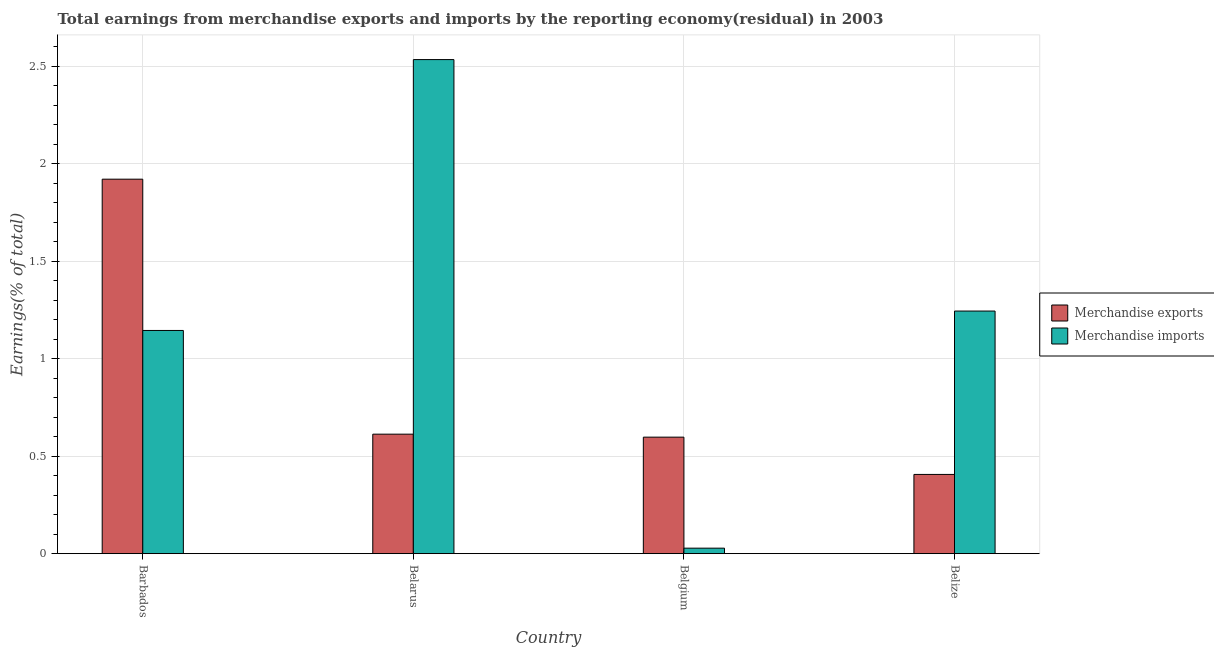Are the number of bars per tick equal to the number of legend labels?
Ensure brevity in your answer.  Yes. Are the number of bars on each tick of the X-axis equal?
Provide a succinct answer. Yes. How many bars are there on the 2nd tick from the left?
Your answer should be very brief. 2. How many bars are there on the 1st tick from the right?
Offer a very short reply. 2. What is the label of the 1st group of bars from the left?
Your answer should be compact. Barbados. What is the earnings from merchandise imports in Belgium?
Provide a short and direct response. 0.03. Across all countries, what is the maximum earnings from merchandise exports?
Provide a short and direct response. 1.92. Across all countries, what is the minimum earnings from merchandise exports?
Keep it short and to the point. 0.41. In which country was the earnings from merchandise exports maximum?
Offer a terse response. Barbados. What is the total earnings from merchandise exports in the graph?
Provide a succinct answer. 3.54. What is the difference between the earnings from merchandise imports in Barbados and that in Belize?
Offer a terse response. -0.1. What is the difference between the earnings from merchandise imports in Belarus and the earnings from merchandise exports in Belgium?
Make the answer very short. 1.94. What is the average earnings from merchandise exports per country?
Offer a terse response. 0.88. What is the difference between the earnings from merchandise exports and earnings from merchandise imports in Belarus?
Offer a terse response. -1.92. What is the ratio of the earnings from merchandise imports in Belarus to that in Belgium?
Offer a very short reply. 90.07. Is the difference between the earnings from merchandise imports in Belgium and Belize greater than the difference between the earnings from merchandise exports in Belgium and Belize?
Make the answer very short. No. What is the difference between the highest and the second highest earnings from merchandise exports?
Provide a succinct answer. 1.31. What is the difference between the highest and the lowest earnings from merchandise exports?
Your answer should be very brief. 1.51. In how many countries, is the earnings from merchandise exports greater than the average earnings from merchandise exports taken over all countries?
Make the answer very short. 1. What does the 1st bar from the left in Belgium represents?
Your response must be concise. Merchandise exports. Are all the bars in the graph horizontal?
Give a very brief answer. No. What is the difference between two consecutive major ticks on the Y-axis?
Offer a terse response. 0.5. Does the graph contain any zero values?
Offer a very short reply. No. Does the graph contain grids?
Offer a terse response. Yes. Where does the legend appear in the graph?
Offer a very short reply. Center right. How are the legend labels stacked?
Your answer should be very brief. Vertical. What is the title of the graph?
Provide a short and direct response. Total earnings from merchandise exports and imports by the reporting economy(residual) in 2003. Does "Secondary Education" appear as one of the legend labels in the graph?
Your response must be concise. No. What is the label or title of the X-axis?
Offer a very short reply. Country. What is the label or title of the Y-axis?
Keep it short and to the point. Earnings(% of total). What is the Earnings(% of total) in Merchandise exports in Barbados?
Your response must be concise. 1.92. What is the Earnings(% of total) in Merchandise imports in Barbados?
Your answer should be very brief. 1.15. What is the Earnings(% of total) of Merchandise exports in Belarus?
Give a very brief answer. 0.61. What is the Earnings(% of total) in Merchandise imports in Belarus?
Your answer should be compact. 2.54. What is the Earnings(% of total) of Merchandise exports in Belgium?
Offer a terse response. 0.6. What is the Earnings(% of total) of Merchandise imports in Belgium?
Your response must be concise. 0.03. What is the Earnings(% of total) of Merchandise exports in Belize?
Offer a terse response. 0.41. What is the Earnings(% of total) of Merchandise imports in Belize?
Ensure brevity in your answer.  1.24. Across all countries, what is the maximum Earnings(% of total) of Merchandise exports?
Your answer should be very brief. 1.92. Across all countries, what is the maximum Earnings(% of total) of Merchandise imports?
Make the answer very short. 2.54. Across all countries, what is the minimum Earnings(% of total) of Merchandise exports?
Keep it short and to the point. 0.41. Across all countries, what is the minimum Earnings(% of total) of Merchandise imports?
Your answer should be very brief. 0.03. What is the total Earnings(% of total) in Merchandise exports in the graph?
Keep it short and to the point. 3.54. What is the total Earnings(% of total) of Merchandise imports in the graph?
Keep it short and to the point. 4.95. What is the difference between the Earnings(% of total) of Merchandise exports in Barbados and that in Belarus?
Your answer should be very brief. 1.31. What is the difference between the Earnings(% of total) in Merchandise imports in Barbados and that in Belarus?
Keep it short and to the point. -1.39. What is the difference between the Earnings(% of total) of Merchandise exports in Barbados and that in Belgium?
Your response must be concise. 1.32. What is the difference between the Earnings(% of total) of Merchandise imports in Barbados and that in Belgium?
Ensure brevity in your answer.  1.12. What is the difference between the Earnings(% of total) of Merchandise exports in Barbados and that in Belize?
Your answer should be very brief. 1.51. What is the difference between the Earnings(% of total) in Merchandise imports in Barbados and that in Belize?
Your answer should be very brief. -0.1. What is the difference between the Earnings(% of total) of Merchandise exports in Belarus and that in Belgium?
Your answer should be very brief. 0.02. What is the difference between the Earnings(% of total) in Merchandise imports in Belarus and that in Belgium?
Provide a succinct answer. 2.51. What is the difference between the Earnings(% of total) of Merchandise exports in Belarus and that in Belize?
Provide a short and direct response. 0.21. What is the difference between the Earnings(% of total) in Merchandise imports in Belarus and that in Belize?
Make the answer very short. 1.29. What is the difference between the Earnings(% of total) of Merchandise exports in Belgium and that in Belize?
Ensure brevity in your answer.  0.19. What is the difference between the Earnings(% of total) in Merchandise imports in Belgium and that in Belize?
Offer a terse response. -1.22. What is the difference between the Earnings(% of total) of Merchandise exports in Barbados and the Earnings(% of total) of Merchandise imports in Belarus?
Provide a succinct answer. -0.61. What is the difference between the Earnings(% of total) of Merchandise exports in Barbados and the Earnings(% of total) of Merchandise imports in Belgium?
Your answer should be very brief. 1.89. What is the difference between the Earnings(% of total) of Merchandise exports in Barbados and the Earnings(% of total) of Merchandise imports in Belize?
Your answer should be compact. 0.68. What is the difference between the Earnings(% of total) of Merchandise exports in Belarus and the Earnings(% of total) of Merchandise imports in Belgium?
Your answer should be compact. 0.58. What is the difference between the Earnings(% of total) of Merchandise exports in Belarus and the Earnings(% of total) of Merchandise imports in Belize?
Offer a very short reply. -0.63. What is the difference between the Earnings(% of total) of Merchandise exports in Belgium and the Earnings(% of total) of Merchandise imports in Belize?
Your answer should be very brief. -0.65. What is the average Earnings(% of total) of Merchandise exports per country?
Offer a terse response. 0.88. What is the average Earnings(% of total) of Merchandise imports per country?
Your response must be concise. 1.24. What is the difference between the Earnings(% of total) in Merchandise exports and Earnings(% of total) in Merchandise imports in Barbados?
Give a very brief answer. 0.78. What is the difference between the Earnings(% of total) of Merchandise exports and Earnings(% of total) of Merchandise imports in Belarus?
Your response must be concise. -1.92. What is the difference between the Earnings(% of total) in Merchandise exports and Earnings(% of total) in Merchandise imports in Belgium?
Your answer should be compact. 0.57. What is the difference between the Earnings(% of total) in Merchandise exports and Earnings(% of total) in Merchandise imports in Belize?
Make the answer very short. -0.84. What is the ratio of the Earnings(% of total) of Merchandise exports in Barbados to that in Belarus?
Ensure brevity in your answer.  3.13. What is the ratio of the Earnings(% of total) in Merchandise imports in Barbados to that in Belarus?
Your answer should be compact. 0.45. What is the ratio of the Earnings(% of total) in Merchandise exports in Barbados to that in Belgium?
Your answer should be compact. 3.21. What is the ratio of the Earnings(% of total) of Merchandise imports in Barbados to that in Belgium?
Offer a very short reply. 40.69. What is the ratio of the Earnings(% of total) in Merchandise exports in Barbados to that in Belize?
Keep it short and to the point. 4.73. What is the ratio of the Earnings(% of total) of Merchandise imports in Barbados to that in Belize?
Provide a short and direct response. 0.92. What is the ratio of the Earnings(% of total) in Merchandise exports in Belarus to that in Belgium?
Provide a succinct answer. 1.03. What is the ratio of the Earnings(% of total) in Merchandise imports in Belarus to that in Belgium?
Keep it short and to the point. 90.07. What is the ratio of the Earnings(% of total) of Merchandise exports in Belarus to that in Belize?
Your response must be concise. 1.51. What is the ratio of the Earnings(% of total) of Merchandise imports in Belarus to that in Belize?
Offer a terse response. 2.04. What is the ratio of the Earnings(% of total) in Merchandise exports in Belgium to that in Belize?
Give a very brief answer. 1.47. What is the ratio of the Earnings(% of total) in Merchandise imports in Belgium to that in Belize?
Your answer should be compact. 0.02. What is the difference between the highest and the second highest Earnings(% of total) of Merchandise exports?
Offer a very short reply. 1.31. What is the difference between the highest and the second highest Earnings(% of total) in Merchandise imports?
Keep it short and to the point. 1.29. What is the difference between the highest and the lowest Earnings(% of total) of Merchandise exports?
Give a very brief answer. 1.51. What is the difference between the highest and the lowest Earnings(% of total) in Merchandise imports?
Offer a very short reply. 2.51. 